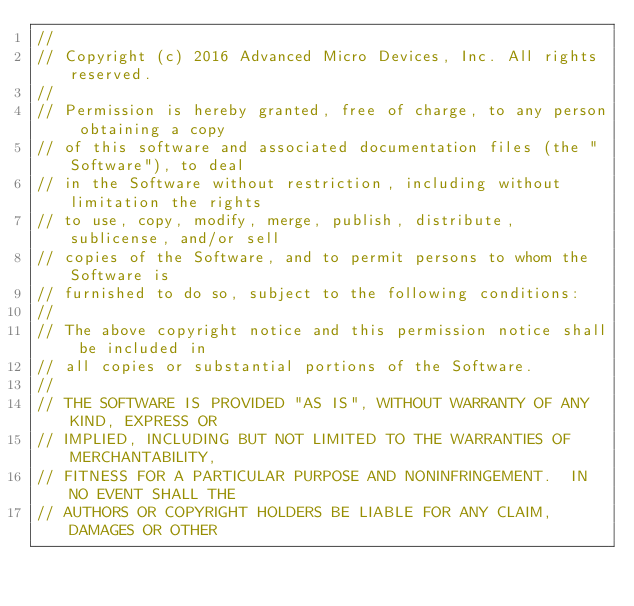Convert code to text. <code><loc_0><loc_0><loc_500><loc_500><_C_>//
// Copyright (c) 2016 Advanced Micro Devices, Inc. All rights reserved.
//
// Permission is hereby granted, free of charge, to any person obtaining a copy
// of this software and associated documentation files (the "Software"), to deal
// in the Software without restriction, including without limitation the rights
// to use, copy, modify, merge, publish, distribute, sublicense, and/or sell
// copies of the Software, and to permit persons to whom the Software is
// furnished to do so, subject to the following conditions:
//
// The above copyright notice and this permission notice shall be included in
// all copies or substantial portions of the Software.
//
// THE SOFTWARE IS PROVIDED "AS IS", WITHOUT WARRANTY OF ANY KIND, EXPRESS OR
// IMPLIED, INCLUDING BUT NOT LIMITED TO THE WARRANTIES OF MERCHANTABILITY,
// FITNESS FOR A PARTICULAR PURPOSE AND NONINFRINGEMENT.  IN NO EVENT SHALL THE
// AUTHORS OR COPYRIGHT HOLDERS BE LIABLE FOR ANY CLAIM, DAMAGES OR OTHER</code> 